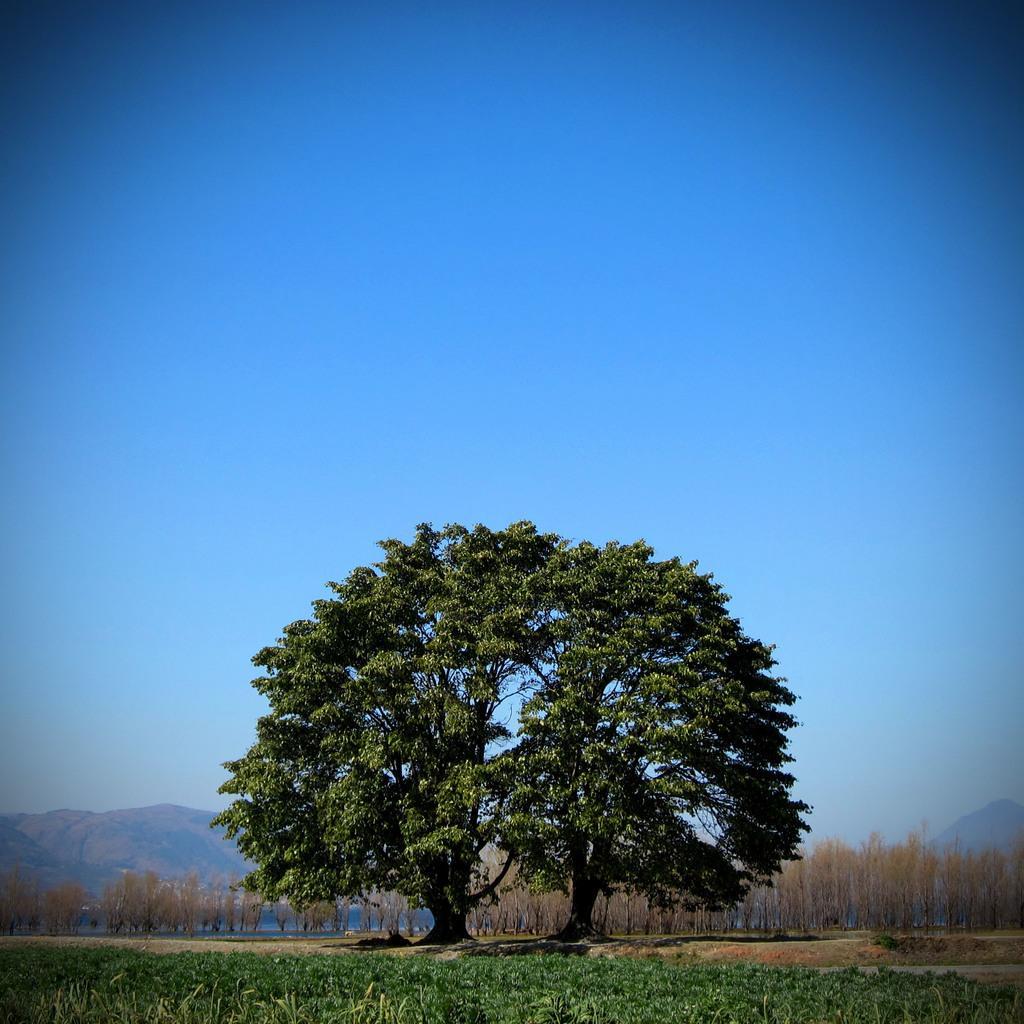Can you describe this image briefly? In this image I can see few plants on the ground which are green in color, the ground and a huge tree which is green and black in color. In the background I can see few trees which are brown in color, few mountains and the sky. 